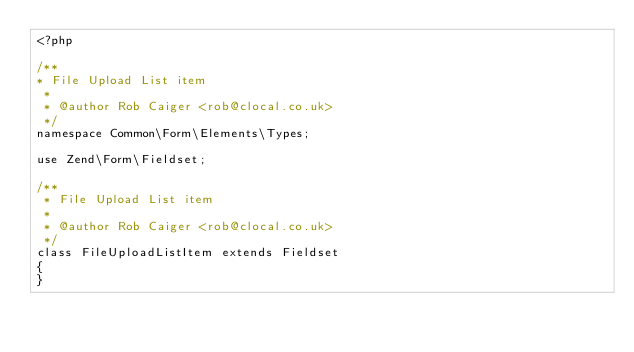<code> <loc_0><loc_0><loc_500><loc_500><_PHP_><?php

/**
* File Upload List item
 *
 * @author Rob Caiger <rob@clocal.co.uk>
 */
namespace Common\Form\Elements\Types;

use Zend\Form\Fieldset;

/**
 * File Upload List item
 *
 * @author Rob Caiger <rob@clocal.co.uk>
 */
class FileUploadListItem extends Fieldset
{
}
</code> 